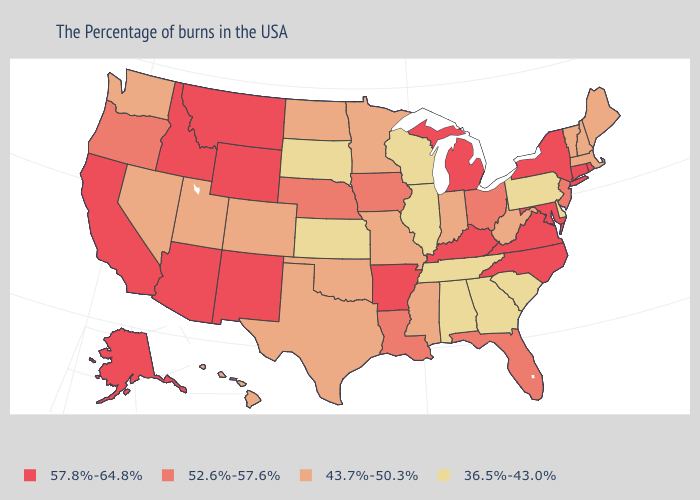What is the highest value in states that border Indiana?
Answer briefly. 57.8%-64.8%. Which states have the lowest value in the South?
Be succinct. Delaware, South Carolina, Georgia, Alabama, Tennessee. What is the lowest value in the Northeast?
Give a very brief answer. 36.5%-43.0%. What is the value of West Virginia?
Give a very brief answer. 43.7%-50.3%. How many symbols are there in the legend?
Give a very brief answer. 4. Which states hav the highest value in the South?
Keep it brief. Maryland, Virginia, North Carolina, Kentucky, Arkansas. Which states hav the highest value in the Northeast?
Keep it brief. Rhode Island, Connecticut, New York. Does Utah have the highest value in the West?
Concise answer only. No. Does the first symbol in the legend represent the smallest category?
Write a very short answer. No. What is the lowest value in the South?
Answer briefly. 36.5%-43.0%. Name the states that have a value in the range 52.6%-57.6%?
Quick response, please. New Jersey, Ohio, Florida, Louisiana, Iowa, Nebraska, Oregon. Which states have the highest value in the USA?
Write a very short answer. Rhode Island, Connecticut, New York, Maryland, Virginia, North Carolina, Michigan, Kentucky, Arkansas, Wyoming, New Mexico, Montana, Arizona, Idaho, California, Alaska. What is the lowest value in the Northeast?
Answer briefly. 36.5%-43.0%. What is the value of North Dakota?
Answer briefly. 43.7%-50.3%. What is the value of Pennsylvania?
Quick response, please. 36.5%-43.0%. 